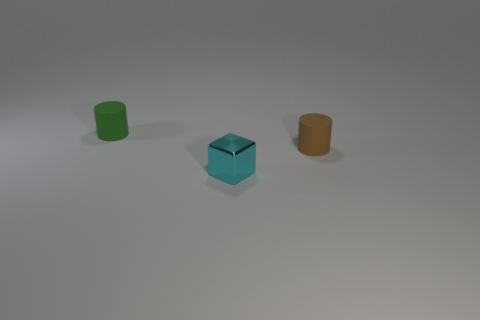Add 3 rubber objects. How many objects exist? 6 Subtract all cylinders. How many objects are left? 1 Subtract all green cylinders. Subtract all gray spheres. How many cylinders are left? 1 Add 2 large green rubber balls. How many large green rubber balls exist? 2 Subtract 0 cyan spheres. How many objects are left? 3 Subtract all brown things. Subtract all cylinders. How many objects are left? 0 Add 3 tiny brown cylinders. How many tiny brown cylinders are left? 4 